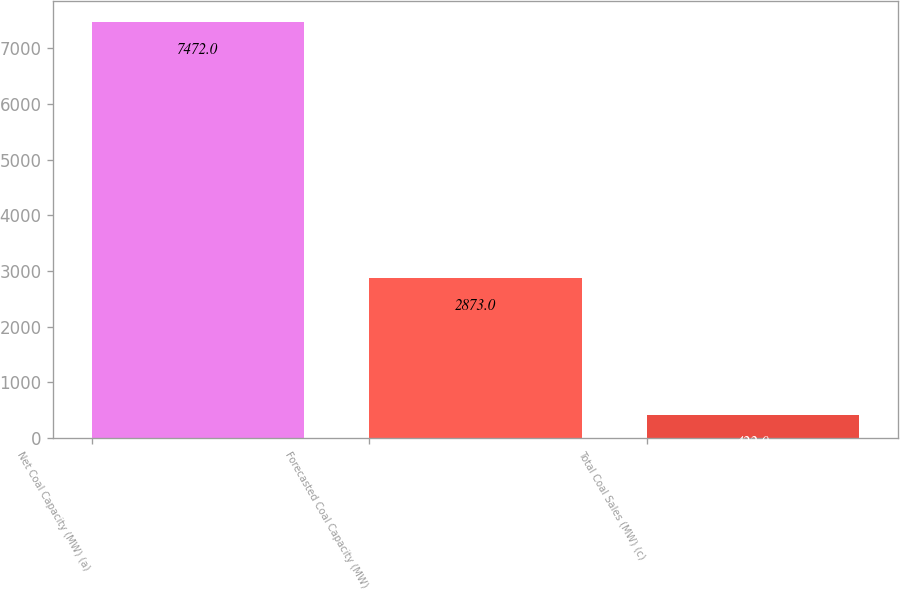Convert chart. <chart><loc_0><loc_0><loc_500><loc_500><bar_chart><fcel>Net Coal Capacity (MW) (a)<fcel>Forecasted Coal Capacity (MW)<fcel>Total Coal Sales (MW) (c)<nl><fcel>7472<fcel>2873<fcel>422<nl></chart> 